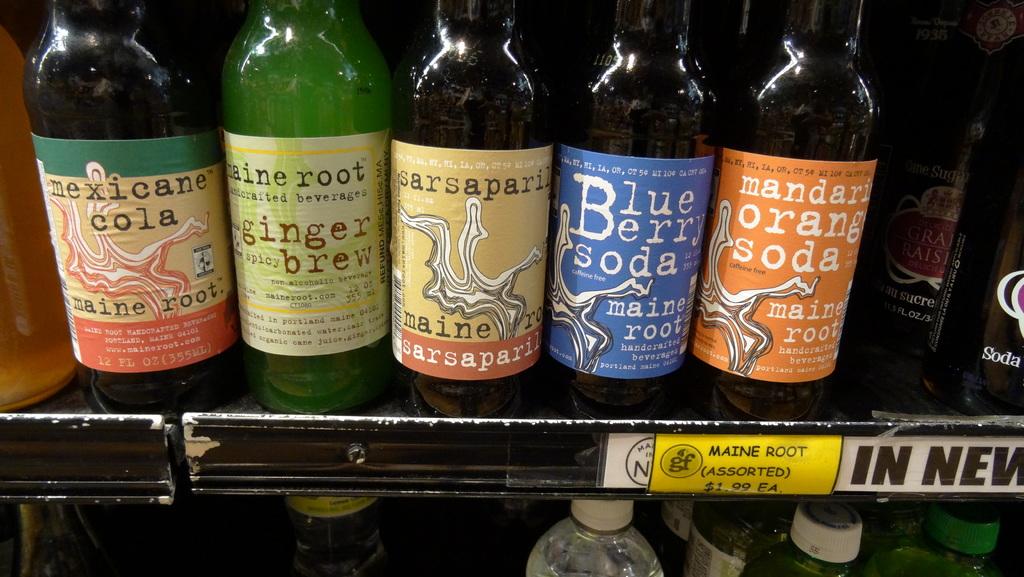What type of drink is the drink to the far left?
Provide a short and direct response. Mexicane cola. What kind of drink is the green one on the left?
Provide a succinct answer. Ginger brew. 